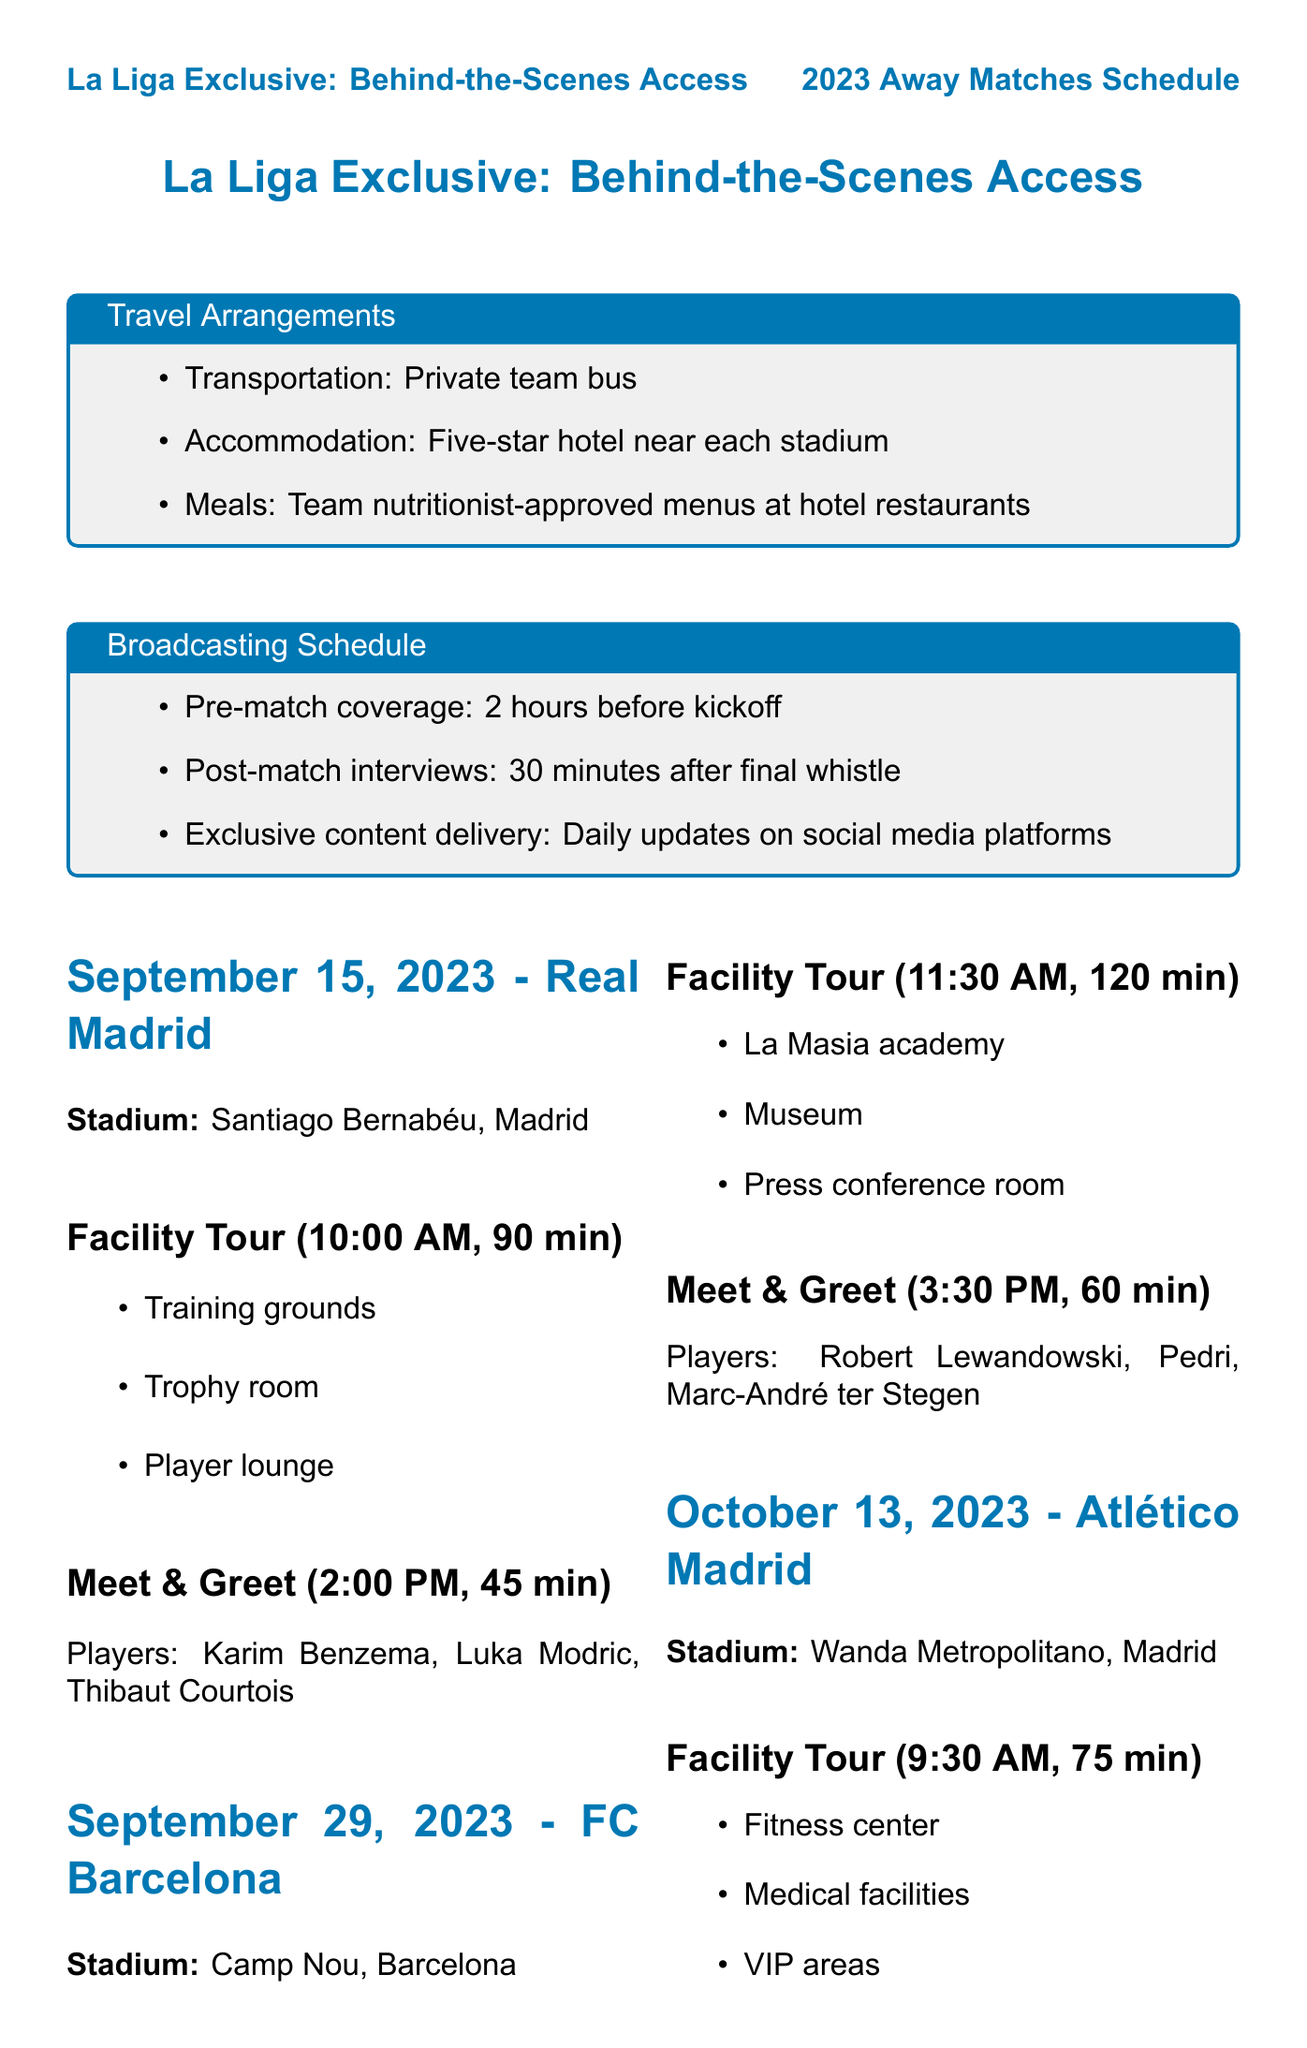what is the home team for the match on September 15, 2023? The document states that the home team for this date is Real Madrid.
Answer: Real Madrid what time does the facility tour start for FC Barcelona on September 29, 2023? The facility tour starts at 11:30 AM as mentioned for this match.
Answer: 11:30 AM how long is the player meet-and-greet for Atlético Madrid? The duration of the meet-and-greet is specified as 45 minutes in the document.
Answer: 45 minutes which players are scheduled for the meet-and-greet on November 10, 2023? The document lists Mikel Oyarzabal, David Silva, and Alexander Isak for this meet-and-greet.
Answer: Mikel Oyarzabal, David Silva, Alexander Isak what is the total duration of the facility tour for Sevilla FC? The facility tour duration for Sevilla FC is provided as 60 minutes in the document.
Answer: 60 minutes what city is the Ramón Sánchez Pizjuán stadium located in? The stadium is located in Seville as stated in the document.
Answer: Seville how many away matches are covered in the document? The document lists a total of six away matches.
Answer: six what transportation method is arranged for travel to away matches? The document specifies that a private team bus is arranged for transportation.
Answer: Private team bus 